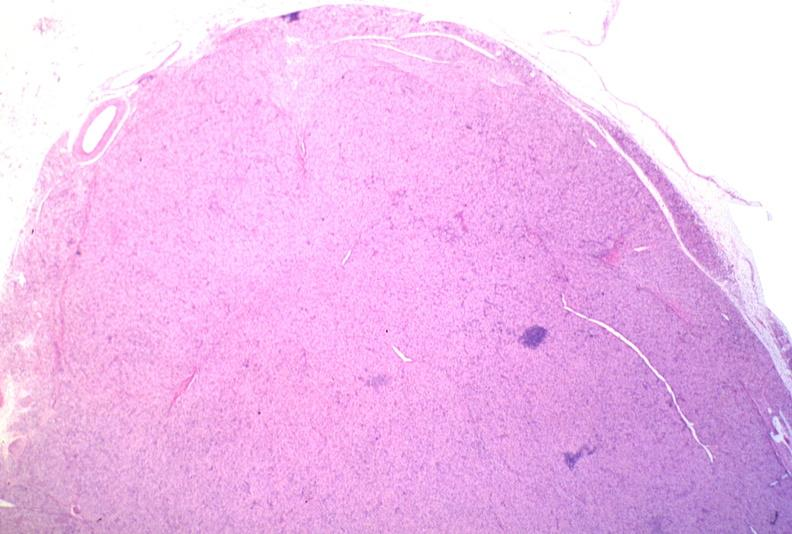what does this image show?
Answer the question using a single word or phrase. Lymph node 